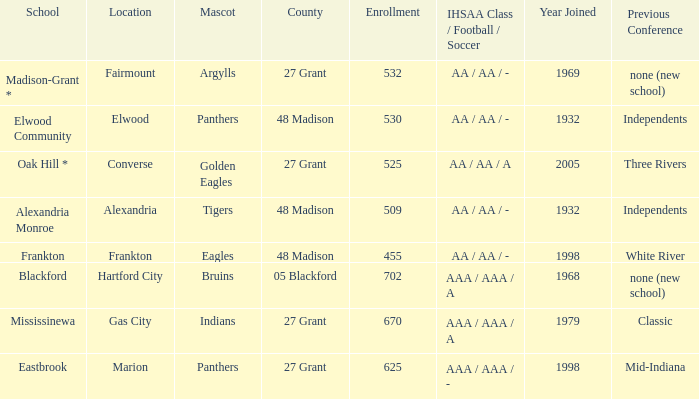What is the school with the location of alexandria? Alexandria Monroe. 